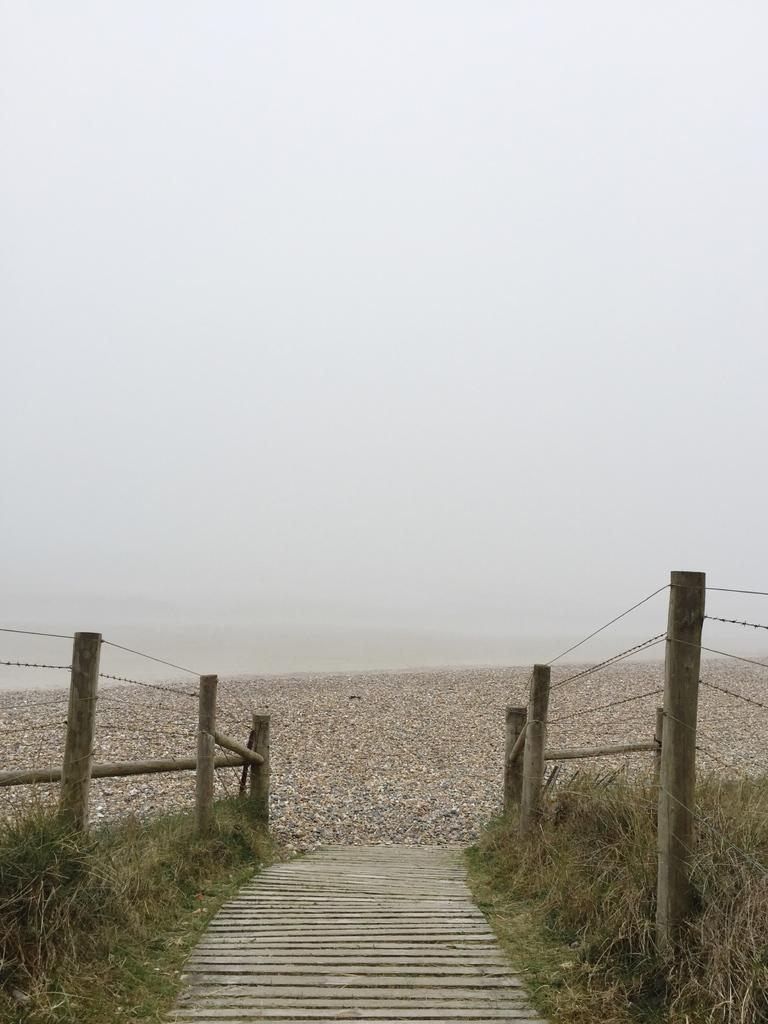What can be seen in the background of the image? The sky is visible in the background of the image. How would you describe the appearance of the sky in the image? The sky appears blurry. What type of vegetation is present on either side of the pathway? There is grass on either side of the pathway. What structures are present on either side of the pathway? There is a fence and poles on either side of the pathway. Where is the shelf located in the image? There is no shelf present in the image. What color is the pencil on the pathway? There is no pencil present in the image. 